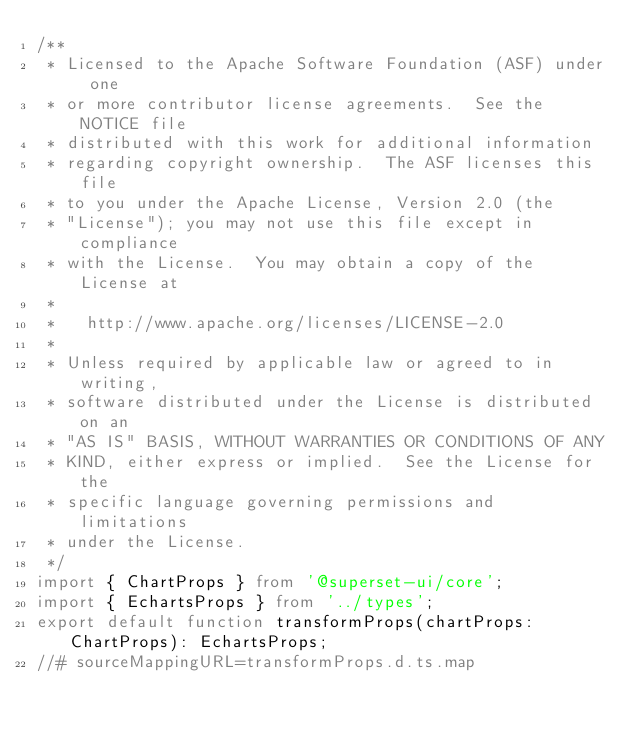Convert code to text. <code><loc_0><loc_0><loc_500><loc_500><_TypeScript_>/**
 * Licensed to the Apache Software Foundation (ASF) under one
 * or more contributor license agreements.  See the NOTICE file
 * distributed with this work for additional information
 * regarding copyright ownership.  The ASF licenses this file
 * to you under the Apache License, Version 2.0 (the
 * "License"); you may not use this file except in compliance
 * with the License.  You may obtain a copy of the License at
 *
 *   http://www.apache.org/licenses/LICENSE-2.0
 *
 * Unless required by applicable law or agreed to in writing,
 * software distributed under the License is distributed on an
 * "AS IS" BASIS, WITHOUT WARRANTIES OR CONDITIONS OF ANY
 * KIND, either express or implied.  See the License for the
 * specific language governing permissions and limitations
 * under the License.
 */
import { ChartProps } from '@superset-ui/core';
import { EchartsProps } from '../types';
export default function transformProps(chartProps: ChartProps): EchartsProps;
//# sourceMappingURL=transformProps.d.ts.map</code> 